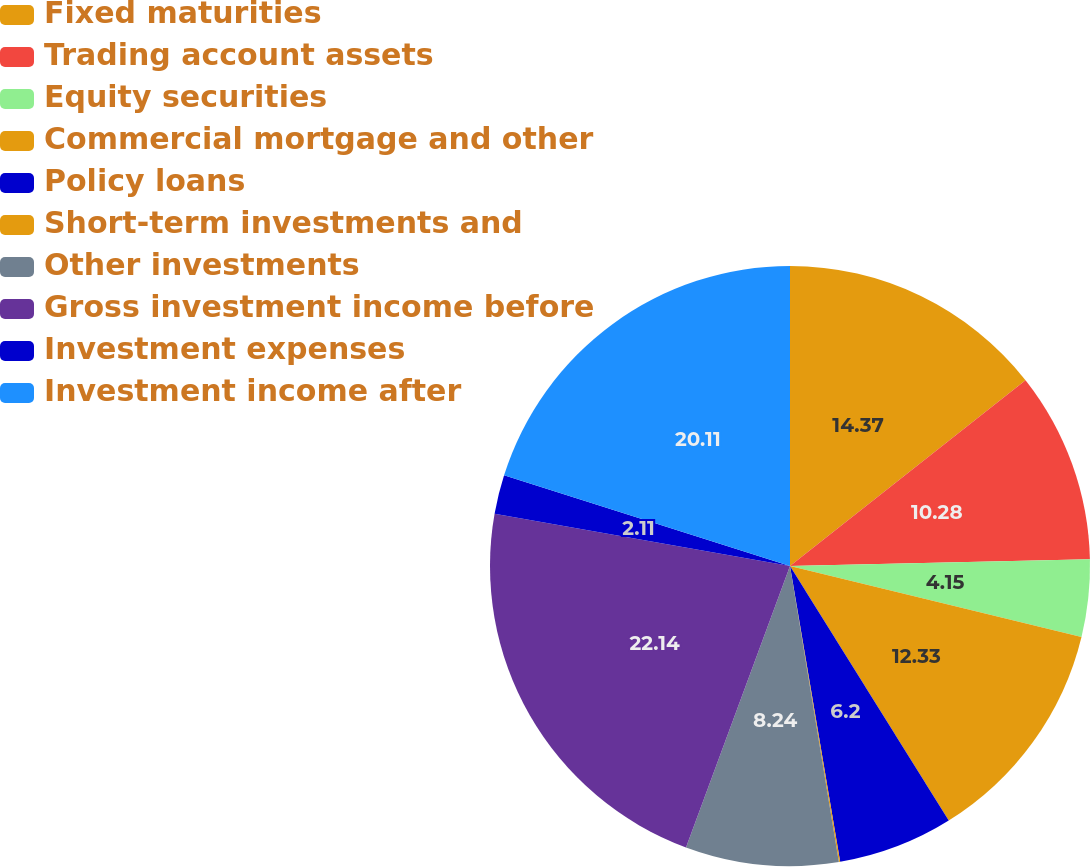Convert chart to OTSL. <chart><loc_0><loc_0><loc_500><loc_500><pie_chart><fcel>Fixed maturities<fcel>Trading account assets<fcel>Equity securities<fcel>Commercial mortgage and other<fcel>Policy loans<fcel>Short-term investments and<fcel>Other investments<fcel>Gross investment income before<fcel>Investment expenses<fcel>Investment income after<nl><fcel>14.37%<fcel>10.28%<fcel>4.15%<fcel>12.33%<fcel>6.2%<fcel>0.07%<fcel>8.24%<fcel>22.15%<fcel>2.11%<fcel>20.11%<nl></chart> 